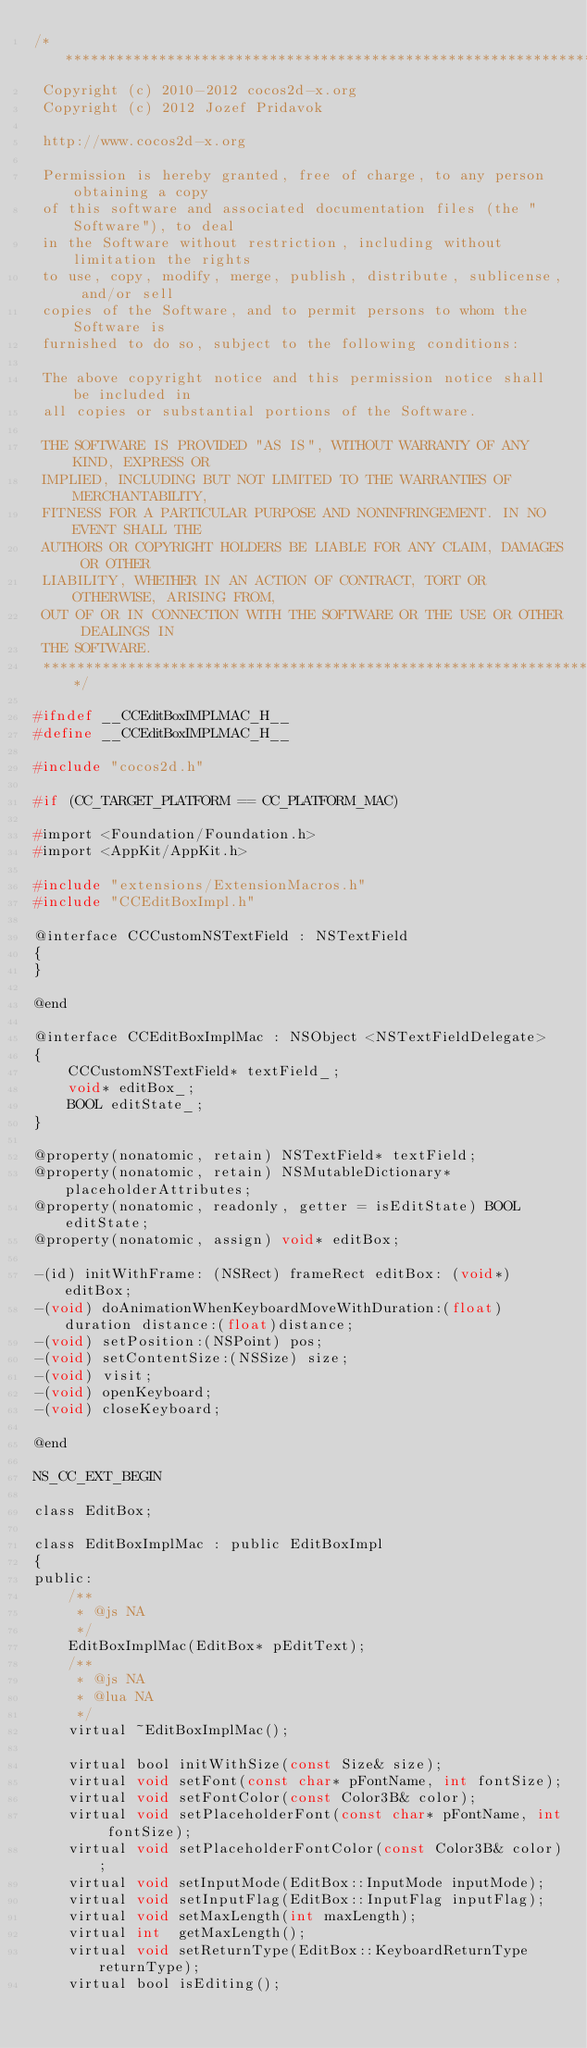Convert code to text. <code><loc_0><loc_0><loc_500><loc_500><_C_>/****************************************************************************
 Copyright (c) 2010-2012 cocos2d-x.org
 Copyright (c) 2012 Jozef Pridavok
 
 http://www.cocos2d-x.org
 
 Permission is hereby granted, free of charge, to any person obtaining a copy
 of this software and associated documentation files (the "Software"), to deal
 in the Software without restriction, including without limitation the rights
 to use, copy, modify, merge, publish, distribute, sublicense, and/or sell
 copies of the Software, and to permit persons to whom the Software is
 furnished to do so, subject to the following conditions:
 
 The above copyright notice and this permission notice shall be included in
 all copies or substantial portions of the Software.
 
 THE SOFTWARE IS PROVIDED "AS IS", WITHOUT WARRANTY OF ANY KIND, EXPRESS OR
 IMPLIED, INCLUDING BUT NOT LIMITED TO THE WARRANTIES OF MERCHANTABILITY,
 FITNESS FOR A PARTICULAR PURPOSE AND NONINFRINGEMENT. IN NO EVENT SHALL THE
 AUTHORS OR COPYRIGHT HOLDERS BE LIABLE FOR ANY CLAIM, DAMAGES OR OTHER
 LIABILITY, WHETHER IN AN ACTION OF CONTRACT, TORT OR OTHERWISE, ARISING FROM,
 OUT OF OR IN CONNECTION WITH THE SOFTWARE OR THE USE OR OTHER DEALINGS IN
 THE SOFTWARE.
 ****************************************************************************/

#ifndef __CCEditBoxIMPLMAC_H__
#define __CCEditBoxIMPLMAC_H__

#include "cocos2d.h"

#if (CC_TARGET_PLATFORM == CC_PLATFORM_MAC)

#import <Foundation/Foundation.h>
#import <AppKit/AppKit.h>

#include "extensions/ExtensionMacros.h"
#include "CCEditBoxImpl.h"

@interface CCCustomNSTextField : NSTextField
{
}

@end

@interface CCEditBoxImplMac : NSObject <NSTextFieldDelegate>
{
    CCCustomNSTextField* textField_;
    void* editBox_;
    BOOL editState_;
}

@property(nonatomic, retain) NSTextField* textField;
@property(nonatomic, retain) NSMutableDictionary* placeholderAttributes;
@property(nonatomic, readonly, getter = isEditState) BOOL editState;
@property(nonatomic, assign) void* editBox;

-(id) initWithFrame: (NSRect) frameRect editBox: (void*) editBox;
-(void) doAnimationWhenKeyboardMoveWithDuration:(float)duration distance:(float)distance;
-(void) setPosition:(NSPoint) pos;
-(void) setContentSize:(NSSize) size;
-(void) visit;
-(void) openKeyboard;
-(void) closeKeyboard;

@end

NS_CC_EXT_BEGIN

class EditBox;

class EditBoxImplMac : public EditBoxImpl
{
public:
    /**
     * @js NA
     */
    EditBoxImplMac(EditBox* pEditText);
    /**
     * @js NA
     * @lua NA
     */
    virtual ~EditBoxImplMac();
    
    virtual bool initWithSize(const Size& size);
    virtual void setFont(const char* pFontName, int fontSize);
    virtual void setFontColor(const Color3B& color);
    virtual void setPlaceholderFont(const char* pFontName, int fontSize);
    virtual void setPlaceholderFontColor(const Color3B& color);
    virtual void setInputMode(EditBox::InputMode inputMode);
    virtual void setInputFlag(EditBox::InputFlag inputFlag);
    virtual void setMaxLength(int maxLength);
    virtual int  getMaxLength();
    virtual void setReturnType(EditBox::KeyboardReturnType returnType);
    virtual bool isEditing();
    </code> 